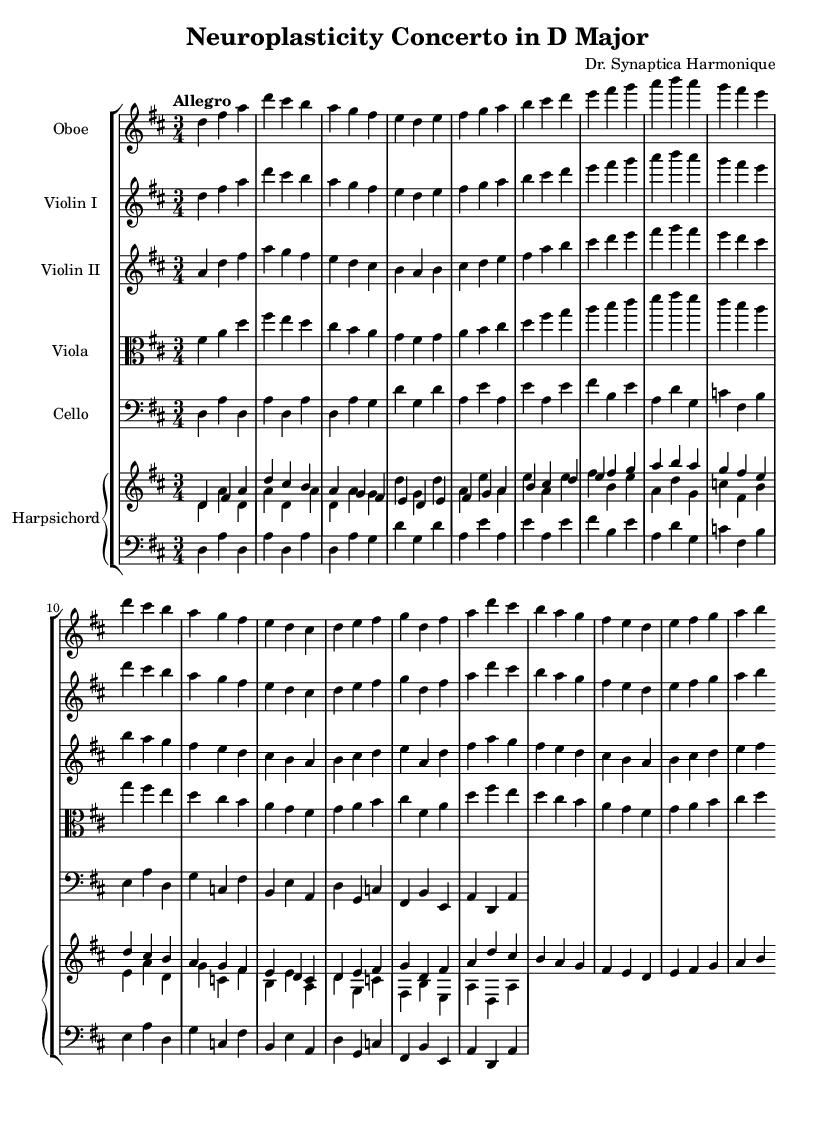What is the key signature of this composition? The key signature is D major, which has two sharps (F# and C#). This can be identified by looking at the key signature notation at the beginning of the score.
Answer: D major What is the time signature of this piece? The time signature shown at the beginning of the score is 3/4, indicating that there are three beats per measure, and the quarter note receives one beat.
Answer: 3/4 What is the tempo marking of the piece? The tempo marking is "Allegro," which is indicated at the start of the score, suggesting a fast and lively pace.
Answer: Allegro How many instruments are featured in this concerto? The score lists a total of five different instruments: Oboe, Two Violins, Viola, Cello, and Harpsichord, which can be counted by looking at the staff groups provided.
Answer: Five Which instrument plays the first melody? The first melody is introduced by the Oboe, as it is written in the first staff of the score and visually distinguishes the melodic lines.
Answer: Oboe What is the key signature of the viola part? The viola part shares the same key signature as the entire composition, which is D major. This is common for orchestral arrangements, where all parts stay within the same key.
Answer: D major What is the musical form of this composition? The composition likely follows a concerto form typical of the Baroque period, characterized by a soloist section contrasted with orchestral sections, which can be inferred from the structure and the presence of a harpsichord.
Answer: Concerto 